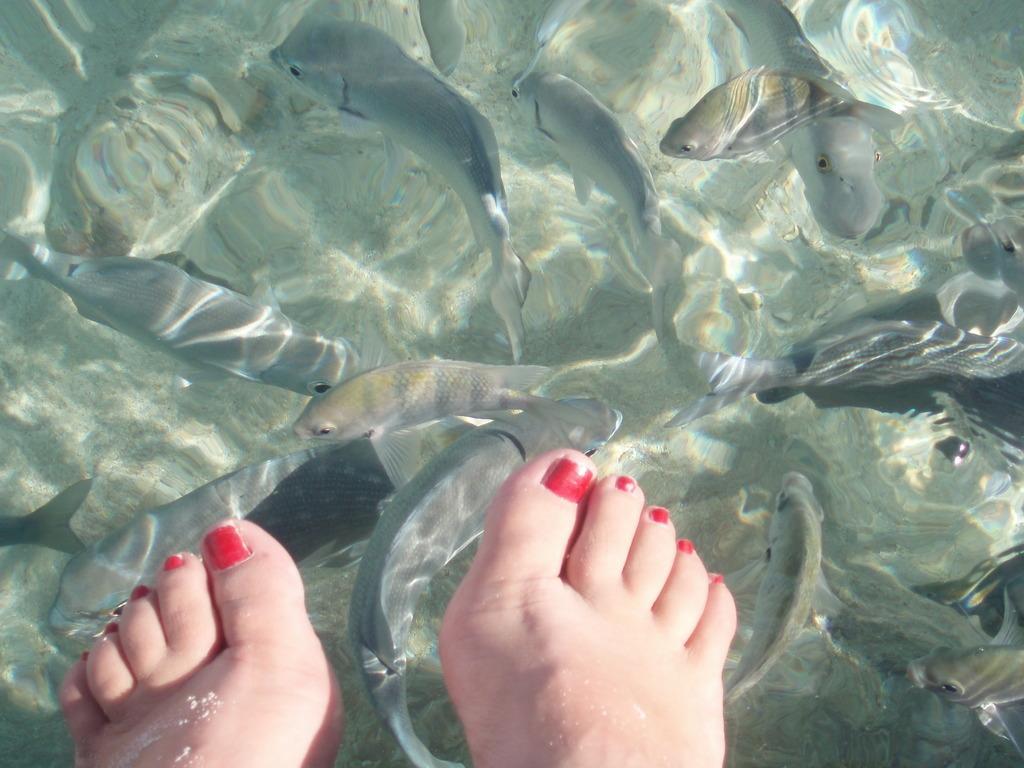Could you give a brief overview of what you see in this image? In this image we can see the legs of a person and fishes in the water. 